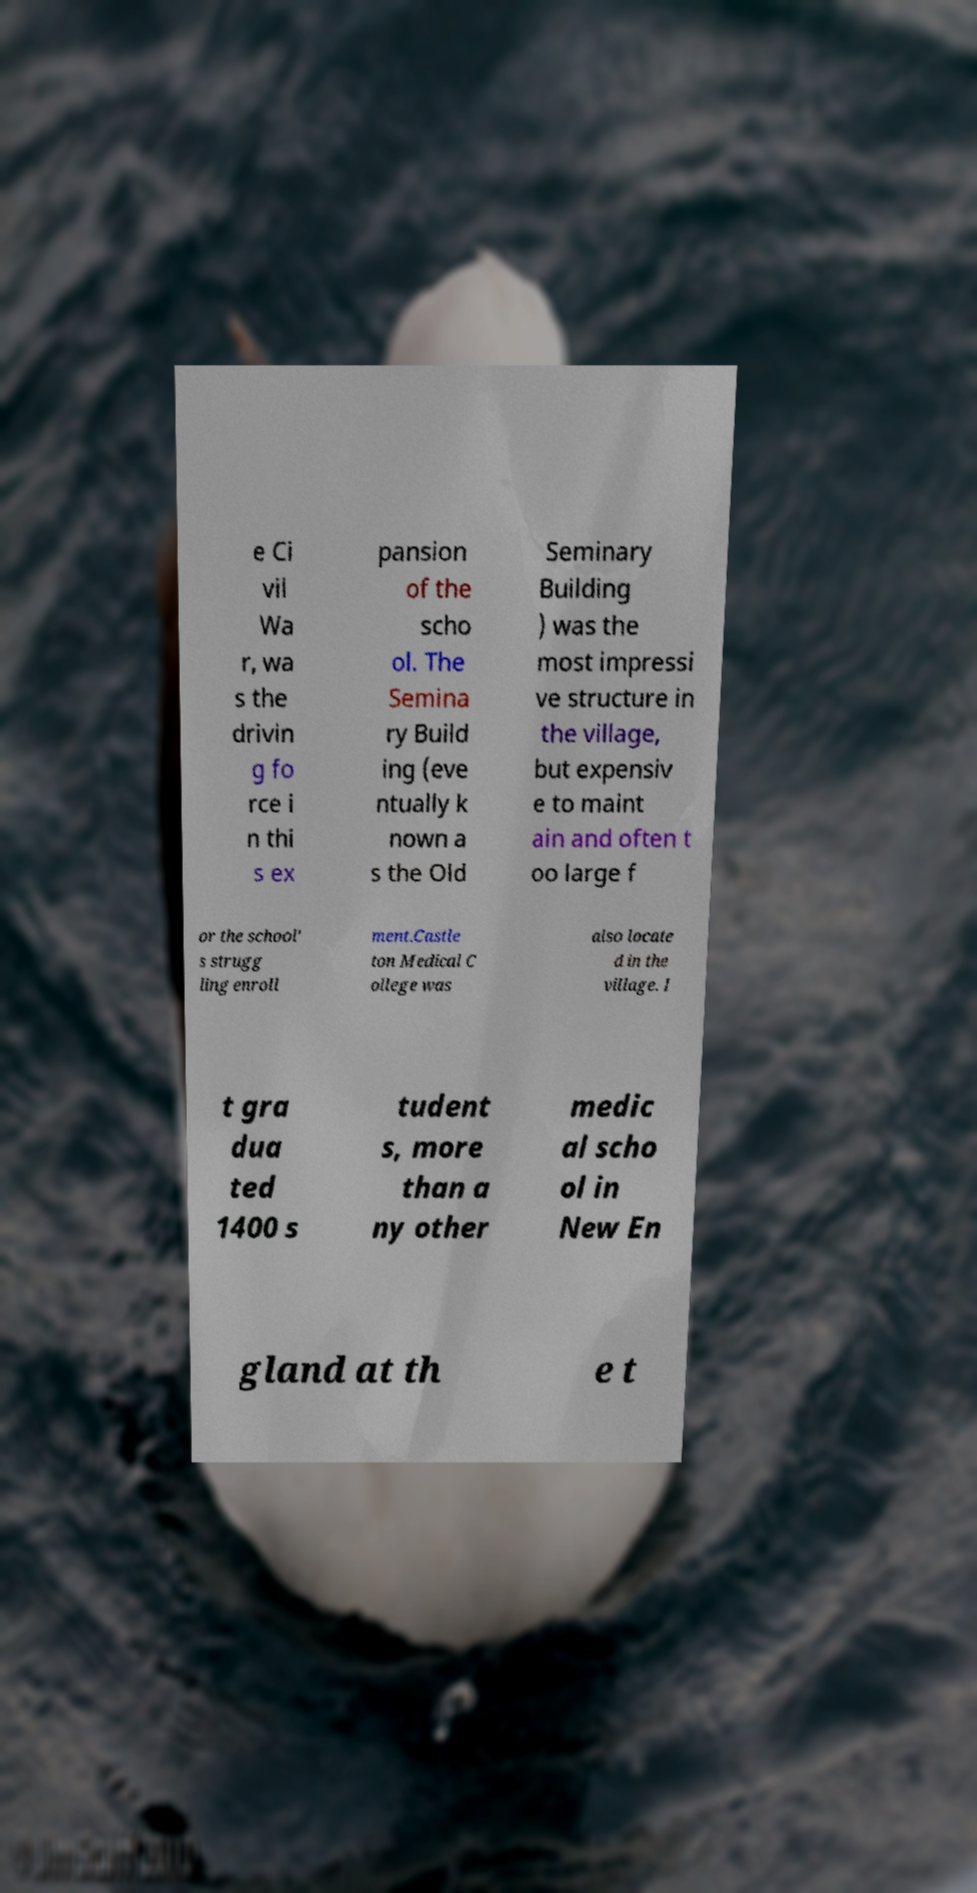Could you assist in decoding the text presented in this image and type it out clearly? e Ci vil Wa r, wa s the drivin g fo rce i n thi s ex pansion of the scho ol. The Semina ry Build ing (eve ntually k nown a s the Old Seminary Building ) was the most impressi ve structure in the village, but expensiv e to maint ain and often t oo large f or the school' s strugg ling enroll ment.Castle ton Medical C ollege was also locate d in the village. I t gra dua ted 1400 s tudent s, more than a ny other medic al scho ol in New En gland at th e t 